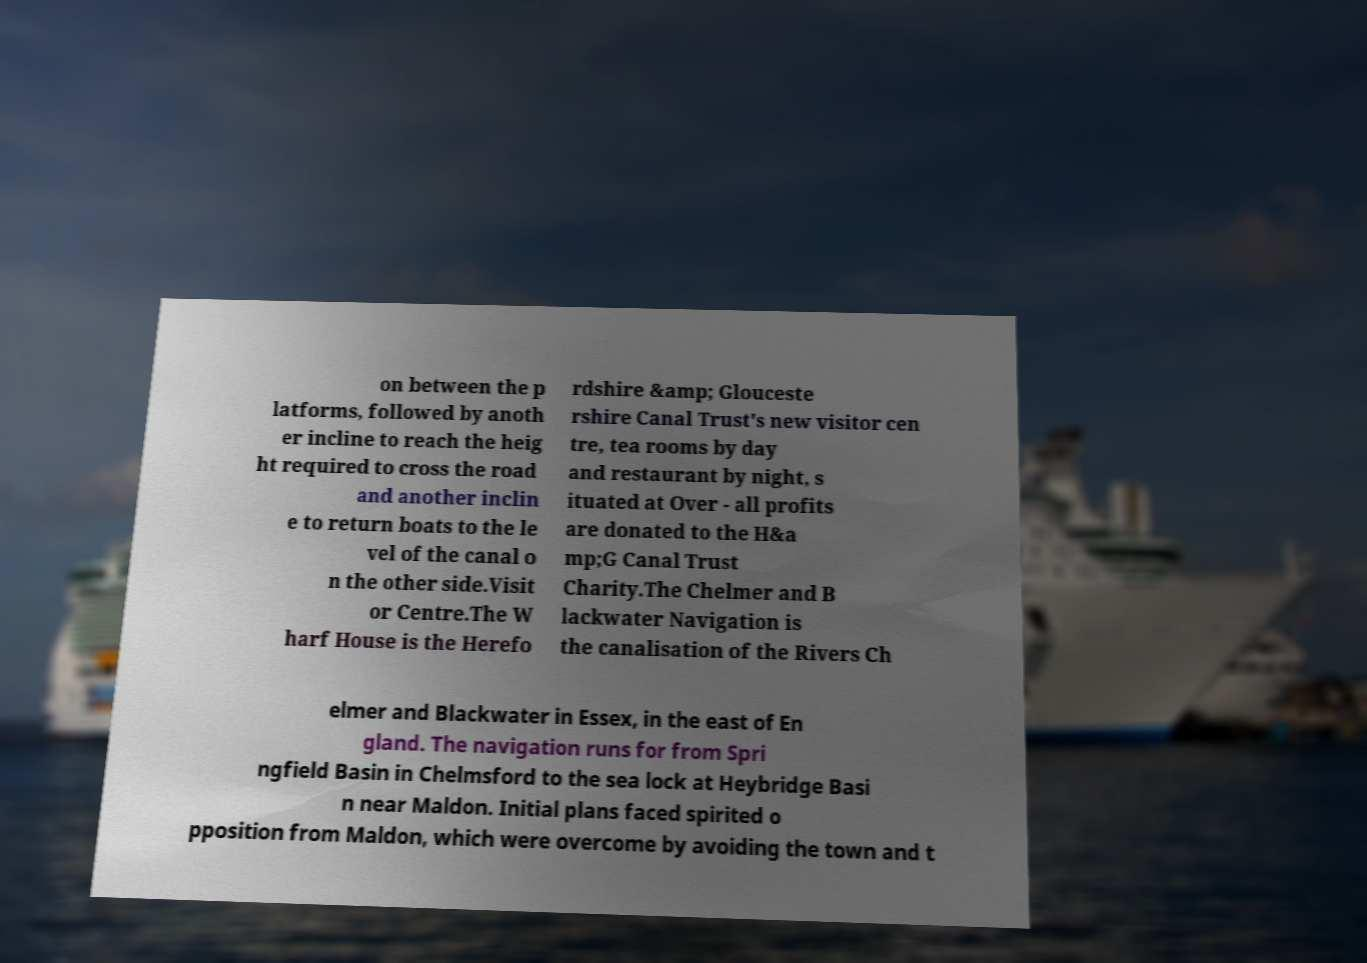Can you read and provide the text displayed in the image?This photo seems to have some interesting text. Can you extract and type it out for me? on between the p latforms, followed by anoth er incline to reach the heig ht required to cross the road and another inclin e to return boats to the le vel of the canal o n the other side.Visit or Centre.The W harf House is the Herefo rdshire &amp; Glouceste rshire Canal Trust's new visitor cen tre, tea rooms by day and restaurant by night, s ituated at Over - all profits are donated to the H&a mp;G Canal Trust Charity.The Chelmer and B lackwater Navigation is the canalisation of the Rivers Ch elmer and Blackwater in Essex, in the east of En gland. The navigation runs for from Spri ngfield Basin in Chelmsford to the sea lock at Heybridge Basi n near Maldon. Initial plans faced spirited o pposition from Maldon, which were overcome by avoiding the town and t 